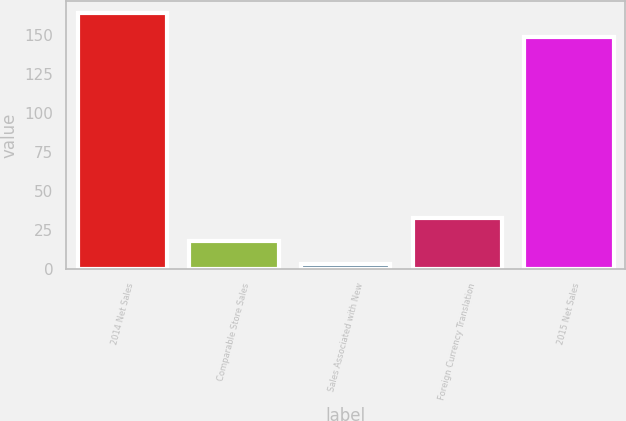<chart> <loc_0><loc_0><loc_500><loc_500><bar_chart><fcel>2014 Net Sales<fcel>Comparable Store Sales<fcel>Sales Associated with New<fcel>Foreign Currency Translation<fcel>2015 Net Sales<nl><fcel>164<fcel>18<fcel>3<fcel>33<fcel>149<nl></chart> 